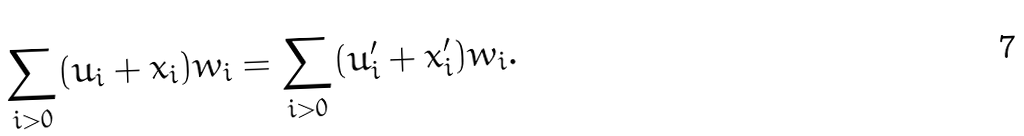<formula> <loc_0><loc_0><loc_500><loc_500>\sum _ { i > 0 } ( u _ { i } + x _ { i } ) w _ { i } = \sum _ { i > 0 } ( u ^ { \prime } _ { i } + x ^ { \prime } _ { i } ) w _ { i } .</formula> 